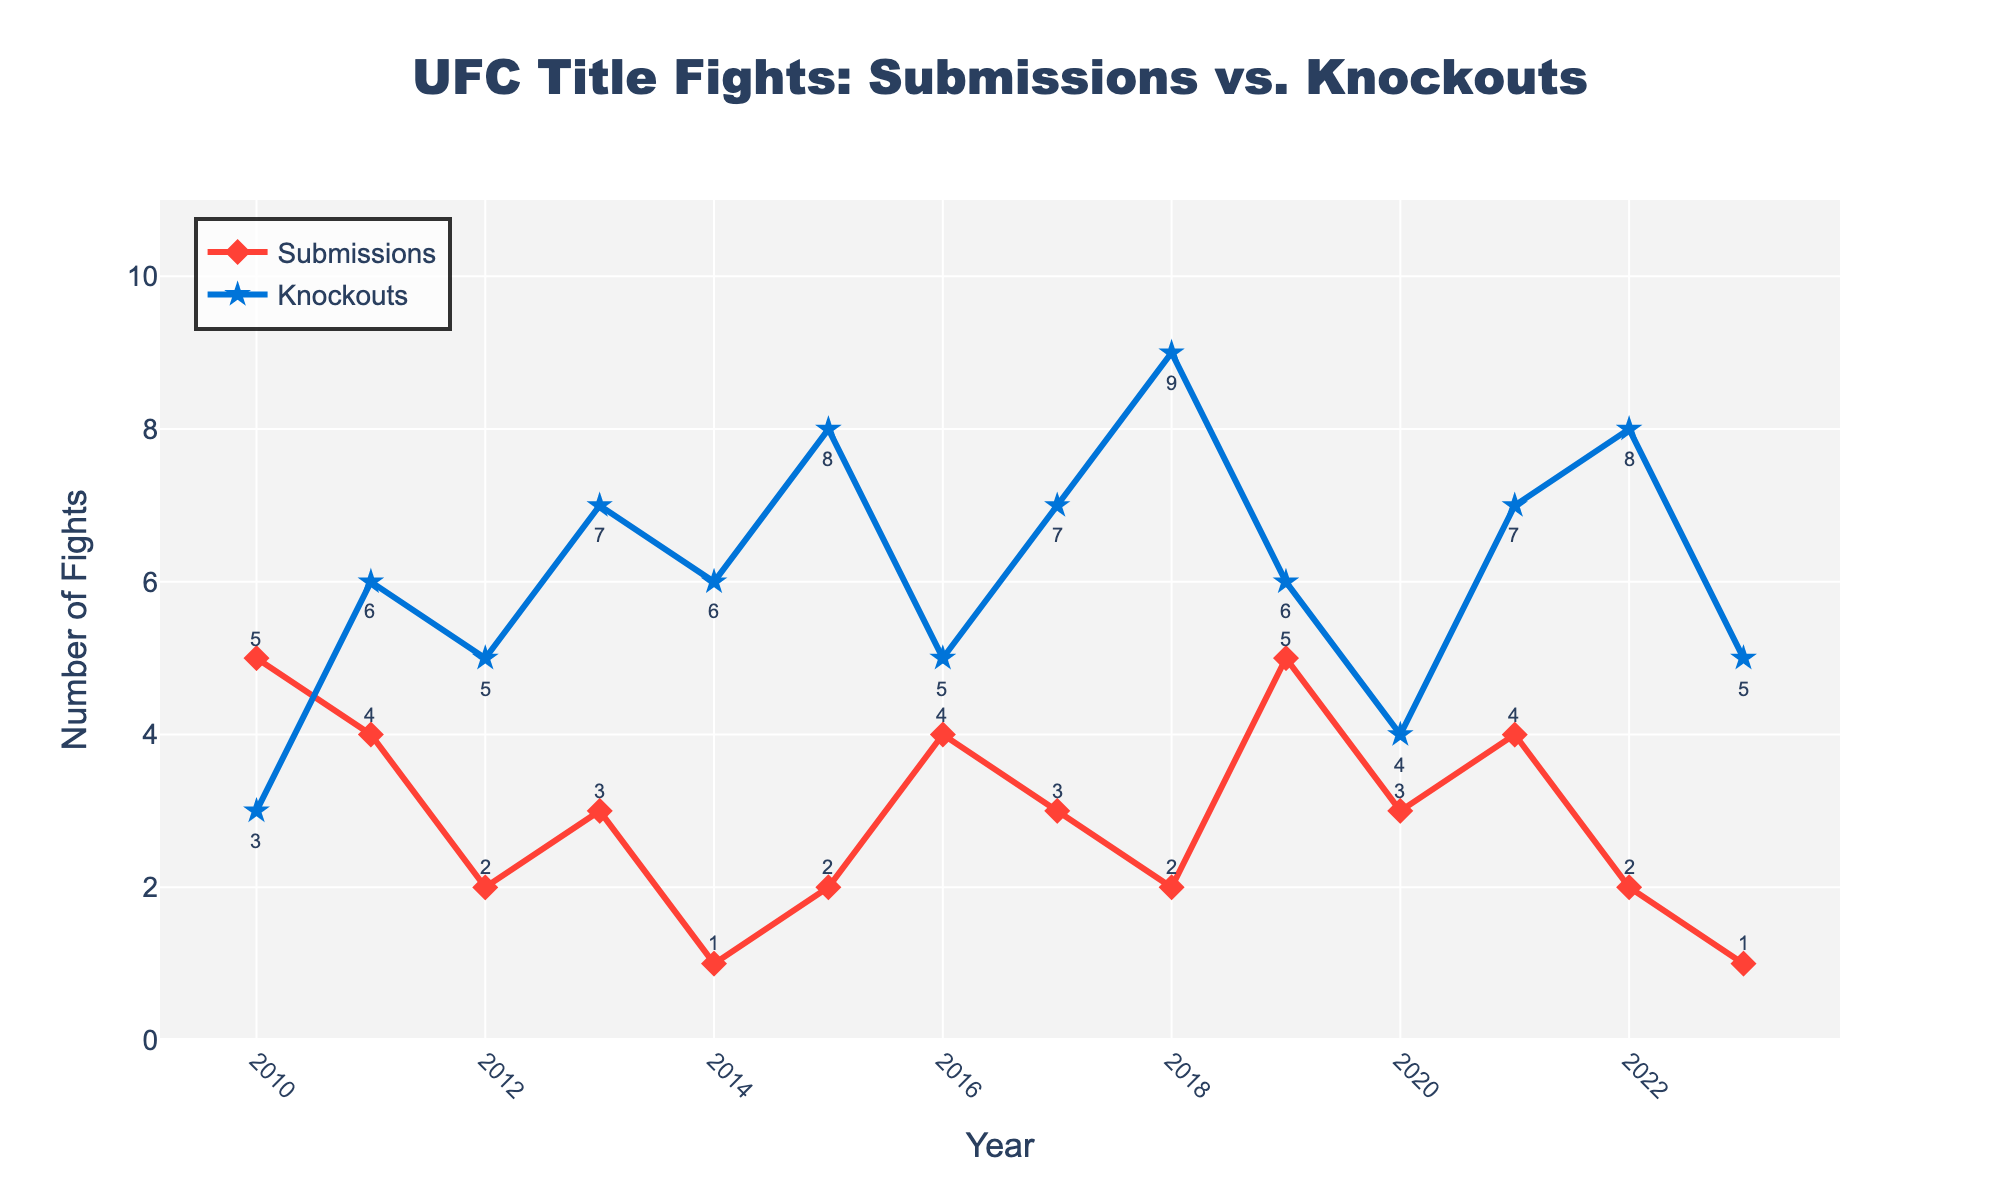What's the total number of submissions and knockouts in 2015? To find the total number of submissions and knockouts in 2015, we need to sum the number of submissions and the number of knockouts for that year. In 2015, there are 2 submissions and 8 knockouts. Thus, the total is 2 + 8 = 10.
Answer: 10 In which year were the knockouts the highest? By inspecting the chart, we see that the number of knockouts peaks when the value is highest. The highest number of knockouts is 9 in 2018.
Answer: 2018 How many more knockouts than submissions were there in 2022? To find the difference between knockouts and submissions for 2022, we subtract the number of submissions from the number of knockouts. In 2022, there are 8 knockouts and 2 submissions. Thus, the difference is 8 - 2 = 6.
Answer: 6 Which year had more submissions than knockouts? By comparing the lines for submissions and knockouts, we see that in 2010 and 2019, the number of submissions (5) is greater than the number of knockouts (3 for 2010 and 6 for 2019).
Answer: 2010, 2019 What's the average number of submissions from 2010 to 2013? To calculate the average number of submissions from 2010 to 2013, we sum the number of submissions for each of these years: 5 (2010), 4 (2011), 2 (2012), and 3 (2013), giving us a total of 5 + 4 + 2 + 3 = 14. There are 4 years in this period, so the average is 14 / 4 = 3.5.
Answer: 3.5 Did the number of submissions ever drop to 1? By examining the chart, we can see that the number of submissions dropped to 1 in 2014 and 2023.
Answer: Yes What's the difference between the highest and lowest number of knockouts across the years? The highest number of knockouts is 9 in 2018, and the lowest number of knockouts is 3 in 2010 and 2020. The difference is 9 - 3 = 6.
Answer: 6 Compare the number of submissions in 2010 and 2023. Which year had more, and by how much? In 2010, there were 5 submissions, while in 2023, there was only 1 submission. The difference is 5 - 1 = 4. So, 2010 had 4 more submissions than 2023.
Answer: 2010 by 4 What's the sum of knockouts in 2018 and 2019? To find the sum of knockouts in 2018 and 2019, we add the number of knockouts for these two years: 9 (2018) + 6 (2019) = 15.
Answer: 15 Did the number of knockouts increase or decrease from 2016 to 2018? To determine this, we look at the number of knockouts in 2016, which is 5, and in 2018, which is 9. The number of knockouts increased by 9 - 5 = 4 from 2016 to 2018.
Answer: Increase by 4 